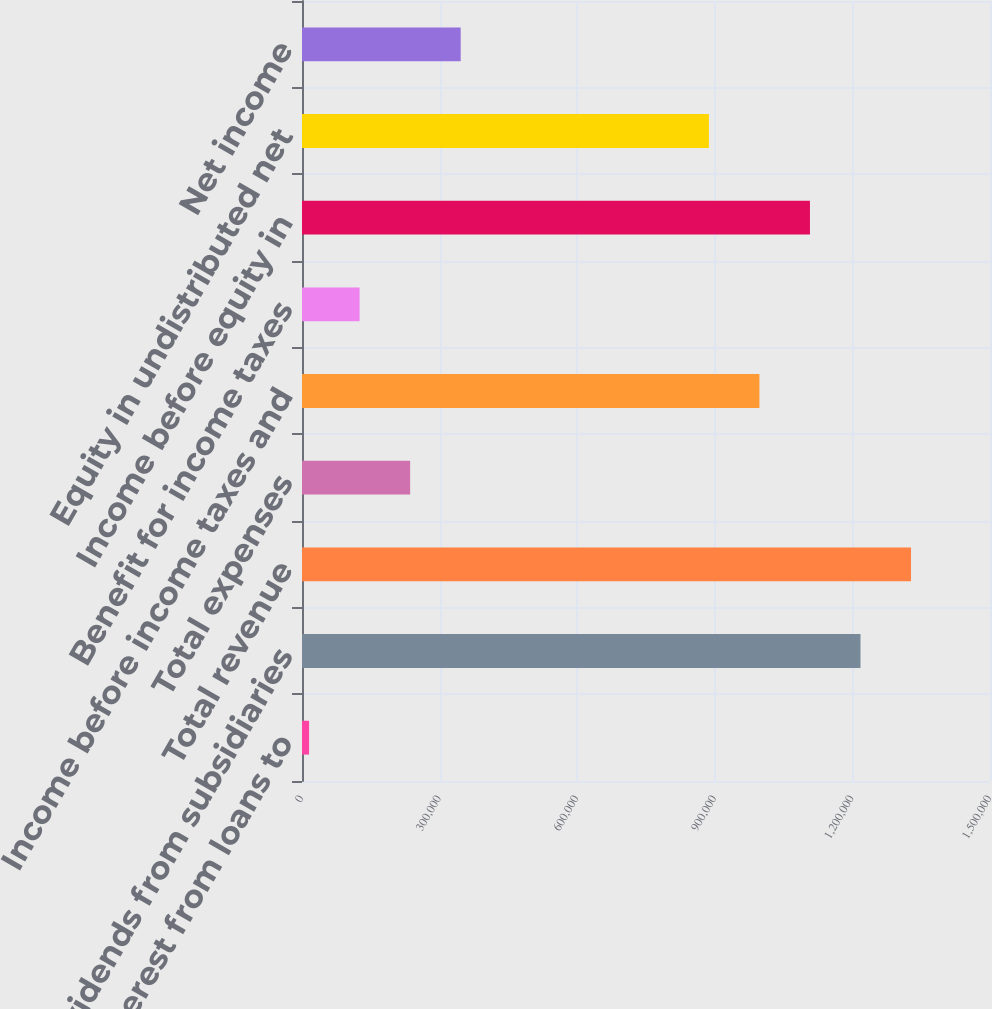<chart> <loc_0><loc_0><loc_500><loc_500><bar_chart><fcel>Interest from loans to<fcel>Dividends from subsidiaries<fcel>Total revenue<fcel>Total expenses<fcel>Income before income taxes and<fcel>Benefit for income taxes<fcel>Income before equity in<fcel>Equity in undistributed net<fcel>Net income<nl><fcel>15428<fcel>1.21764e+06<fcel>1.3278e+06<fcel>235756<fcel>997308<fcel>125592<fcel>1.10747e+06<fcel>887144<fcel>345920<nl></chart> 